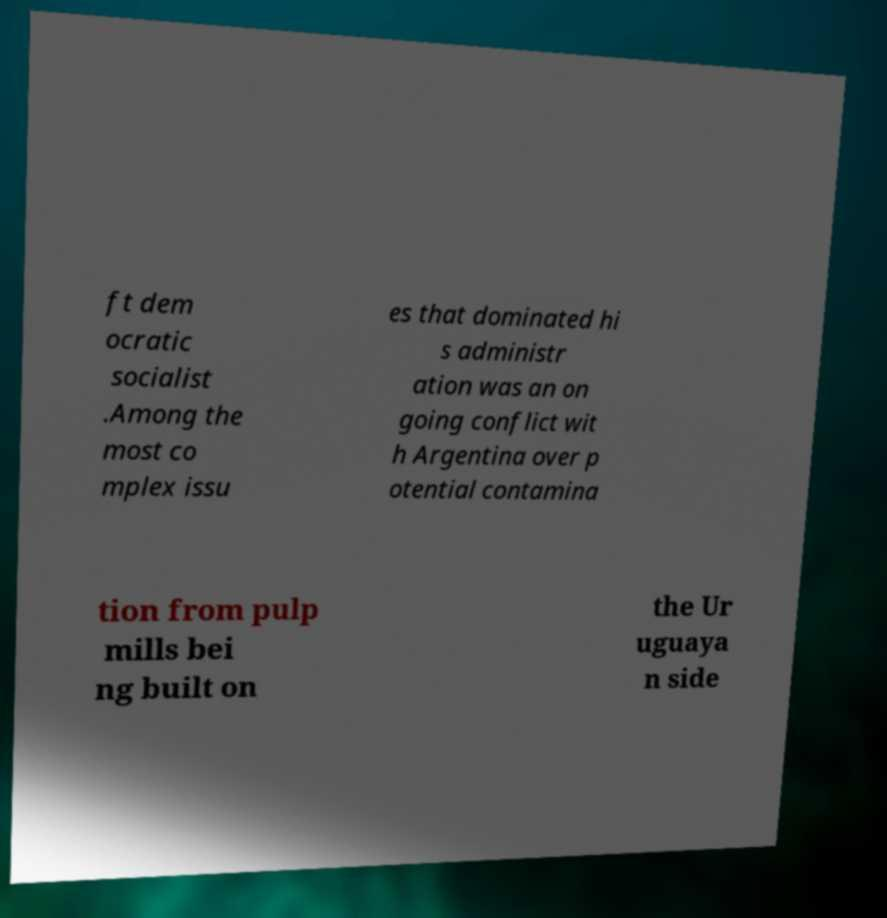What messages or text are displayed in this image? I need them in a readable, typed format. ft dem ocratic socialist .Among the most co mplex issu es that dominated hi s administr ation was an on going conflict wit h Argentina over p otential contamina tion from pulp mills bei ng built on the Ur uguaya n side 